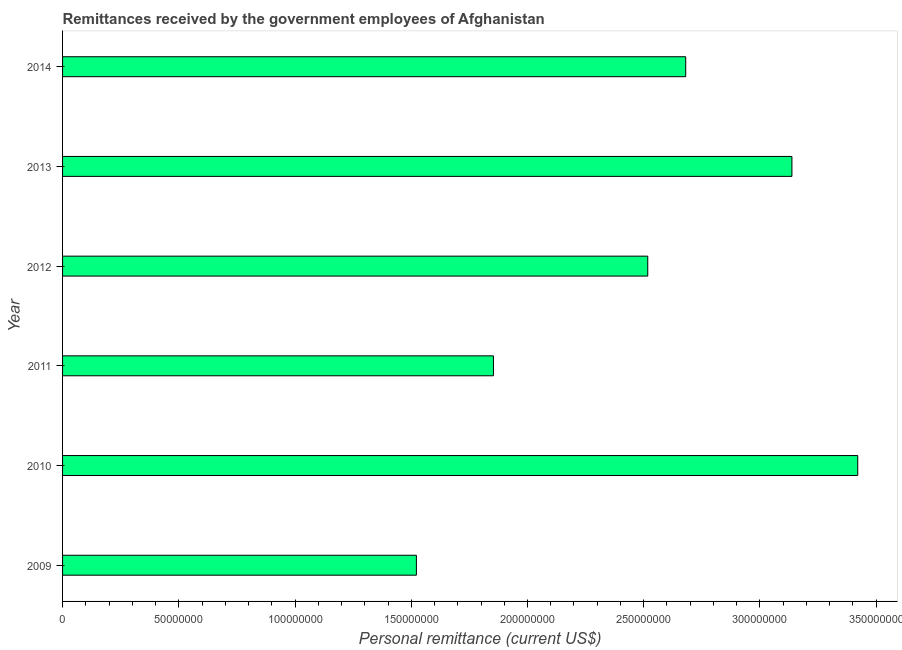Does the graph contain grids?
Keep it short and to the point. No. What is the title of the graph?
Provide a succinct answer. Remittances received by the government employees of Afghanistan. What is the label or title of the X-axis?
Provide a short and direct response. Personal remittance (current US$). What is the personal remittances in 2010?
Give a very brief answer. 3.42e+08. Across all years, what is the maximum personal remittances?
Offer a very short reply. 3.42e+08. Across all years, what is the minimum personal remittances?
Your response must be concise. 1.52e+08. In which year was the personal remittances maximum?
Make the answer very short. 2010. In which year was the personal remittances minimum?
Provide a succinct answer. 2009. What is the sum of the personal remittances?
Your answer should be very brief. 1.51e+09. What is the difference between the personal remittances in 2012 and 2013?
Your answer should be very brief. -6.20e+07. What is the average personal remittances per year?
Offer a terse response. 2.52e+08. What is the median personal remittances?
Ensure brevity in your answer.  2.60e+08. What is the ratio of the personal remittances in 2012 to that in 2013?
Offer a very short reply. 0.8. Is the difference between the personal remittances in 2010 and 2012 greater than the difference between any two years?
Your answer should be compact. No. What is the difference between the highest and the second highest personal remittances?
Provide a short and direct response. 2.83e+07. Is the sum of the personal remittances in 2011 and 2012 greater than the maximum personal remittances across all years?
Offer a terse response. Yes. What is the difference between the highest and the lowest personal remittances?
Ensure brevity in your answer.  1.90e+08. How many years are there in the graph?
Keep it short and to the point. 6. What is the difference between two consecutive major ticks on the X-axis?
Offer a very short reply. 5.00e+07. Are the values on the major ticks of X-axis written in scientific E-notation?
Keep it short and to the point. No. What is the Personal remittance (current US$) in 2009?
Give a very brief answer. 1.52e+08. What is the Personal remittance (current US$) in 2010?
Your answer should be compact. 3.42e+08. What is the Personal remittance (current US$) in 2011?
Your response must be concise. 1.85e+08. What is the Personal remittance (current US$) of 2012?
Offer a terse response. 2.52e+08. What is the Personal remittance (current US$) in 2013?
Provide a short and direct response. 3.14e+08. What is the Personal remittance (current US$) of 2014?
Provide a short and direct response. 2.68e+08. What is the difference between the Personal remittance (current US$) in 2009 and 2010?
Your answer should be compact. -1.90e+08. What is the difference between the Personal remittance (current US$) in 2009 and 2011?
Ensure brevity in your answer.  -3.31e+07. What is the difference between the Personal remittance (current US$) in 2009 and 2012?
Ensure brevity in your answer.  -9.95e+07. What is the difference between the Personal remittance (current US$) in 2009 and 2013?
Offer a very short reply. -1.62e+08. What is the difference between the Personal remittance (current US$) in 2009 and 2014?
Ensure brevity in your answer.  -1.16e+08. What is the difference between the Personal remittance (current US$) in 2010 and 2011?
Your response must be concise. 1.57e+08. What is the difference between the Personal remittance (current US$) in 2010 and 2012?
Offer a very short reply. 9.03e+07. What is the difference between the Personal remittance (current US$) in 2010 and 2013?
Ensure brevity in your answer.  2.83e+07. What is the difference between the Personal remittance (current US$) in 2010 and 2014?
Offer a very short reply. 7.40e+07. What is the difference between the Personal remittance (current US$) in 2011 and 2012?
Offer a very short reply. -6.64e+07. What is the difference between the Personal remittance (current US$) in 2011 and 2013?
Your response must be concise. -1.28e+08. What is the difference between the Personal remittance (current US$) in 2011 and 2014?
Your response must be concise. -8.27e+07. What is the difference between the Personal remittance (current US$) in 2012 and 2013?
Offer a terse response. -6.20e+07. What is the difference between the Personal remittance (current US$) in 2012 and 2014?
Provide a short and direct response. -1.63e+07. What is the difference between the Personal remittance (current US$) in 2013 and 2014?
Give a very brief answer. 4.57e+07. What is the ratio of the Personal remittance (current US$) in 2009 to that in 2010?
Your response must be concise. 0.45. What is the ratio of the Personal remittance (current US$) in 2009 to that in 2011?
Offer a terse response. 0.82. What is the ratio of the Personal remittance (current US$) in 2009 to that in 2012?
Offer a very short reply. 0.6. What is the ratio of the Personal remittance (current US$) in 2009 to that in 2013?
Offer a terse response. 0.48. What is the ratio of the Personal remittance (current US$) in 2009 to that in 2014?
Offer a very short reply. 0.57. What is the ratio of the Personal remittance (current US$) in 2010 to that in 2011?
Your response must be concise. 1.85. What is the ratio of the Personal remittance (current US$) in 2010 to that in 2012?
Offer a terse response. 1.36. What is the ratio of the Personal remittance (current US$) in 2010 to that in 2013?
Give a very brief answer. 1.09. What is the ratio of the Personal remittance (current US$) in 2010 to that in 2014?
Your answer should be compact. 1.28. What is the ratio of the Personal remittance (current US$) in 2011 to that in 2012?
Your answer should be very brief. 0.74. What is the ratio of the Personal remittance (current US$) in 2011 to that in 2013?
Keep it short and to the point. 0.59. What is the ratio of the Personal remittance (current US$) in 2011 to that in 2014?
Give a very brief answer. 0.69. What is the ratio of the Personal remittance (current US$) in 2012 to that in 2013?
Provide a short and direct response. 0.8. What is the ratio of the Personal remittance (current US$) in 2012 to that in 2014?
Offer a very short reply. 0.94. What is the ratio of the Personal remittance (current US$) in 2013 to that in 2014?
Your response must be concise. 1.17. 